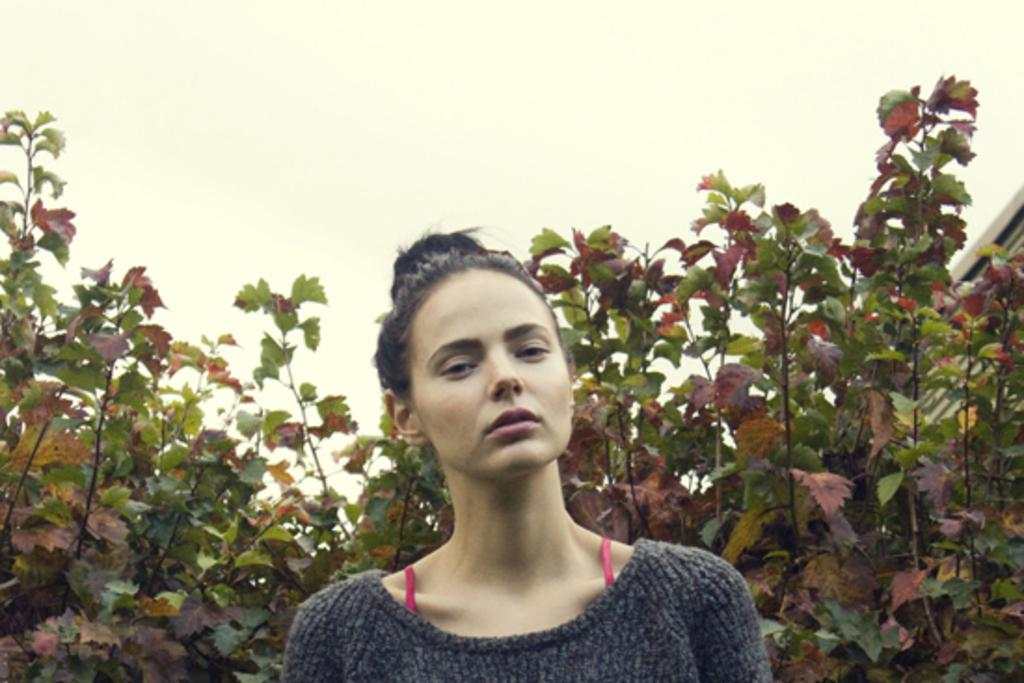Who is the main subject in the image? There is a woman in the image. What is the woman wearing? The woman is wearing a grey sweatshirt. What can be seen behind the woman? There are plants behind the woman. What is visible in the background of the image? The sky is visible in the background of the image. What type of creature is interacting with the woman in the image? There is no creature present in the image; it only features the woman and the plants behind her. 